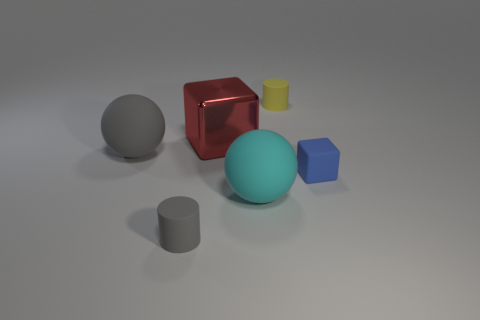Is there an object that seems out of place compared to the others? All objects present flat or matte textures, with the exception of the red cube, which is noticeably reflective, suggesting a different material composition. What could indicate that the red cube is made of a different material? The red cube's high-gloss finish, sharp edges, and distinct reflection of light compared to the other objects suggest it's likely made of a polished material such as glass or metal. 